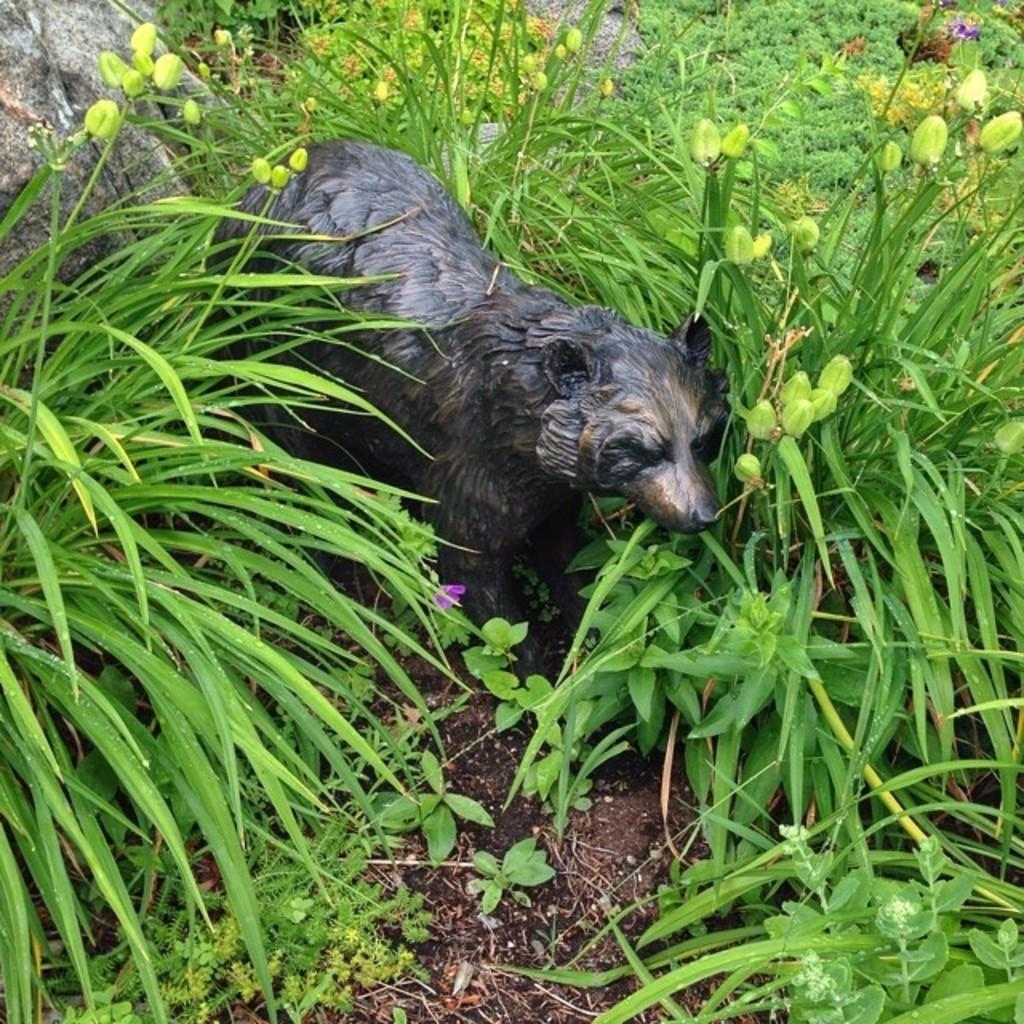What is the main subject in the foreground of the image? There is a dog's sculpture in the foreground of the image. What type of natural environment is visible in the foreground of the image? Grass, plants, and rocks are present in the foreground of the image. What might be the setting of the image based on the visible elements? The image may have been taken in a forest, given the presence of plants and rocks. What type of lip balm is the governor using in the image? There is no governor or lip balm present in the image; it features a dog's sculpture in a natural environment. 